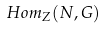Convert formula to latex. <formula><loc_0><loc_0><loc_500><loc_500>H o m _ { Z } ( N , G )</formula> 